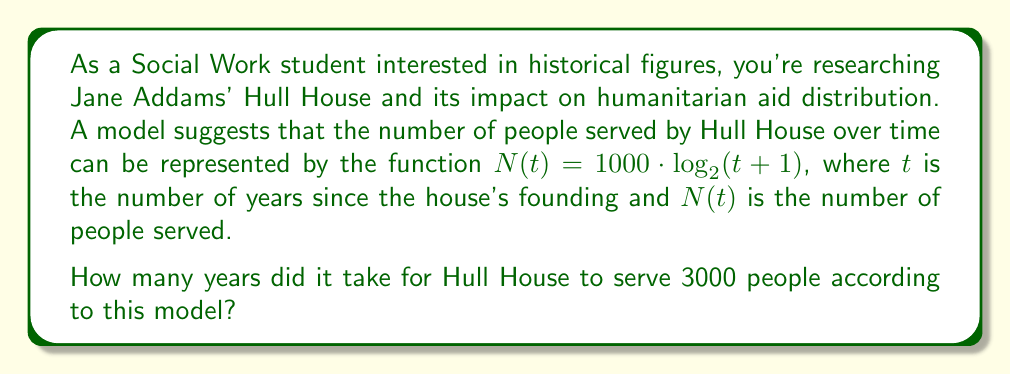Could you help me with this problem? To solve this problem, we need to use the given logarithmic function and solve for $t$ when $N(t) = 3000$. Let's approach this step-by-step:

1) We start with the equation:
   $N(t) = 1000 \cdot \log_2(t+1)$

2) We want to find $t$ when $N(t) = 3000$, so we substitute:
   $3000 = 1000 \cdot \log_2(t+1)$

3) Divide both sides by 1000:
   $3 = \log_2(t+1)$

4) To solve for $t$, we need to apply the inverse function (exponential) to both sides:
   $2^3 = t+1$

5) Simplify the left side:
   $8 = t+1$

6) Subtract 1 from both sides:
   $7 = t$

Therefore, according to this model, it took 7 years for Hull House to serve 3000 people.

This problem demonstrates how logarithmic models can be used to analyze growth in humanitarian aid distribution, connecting mathematics to the historical context of social work.
Answer: 7 years 